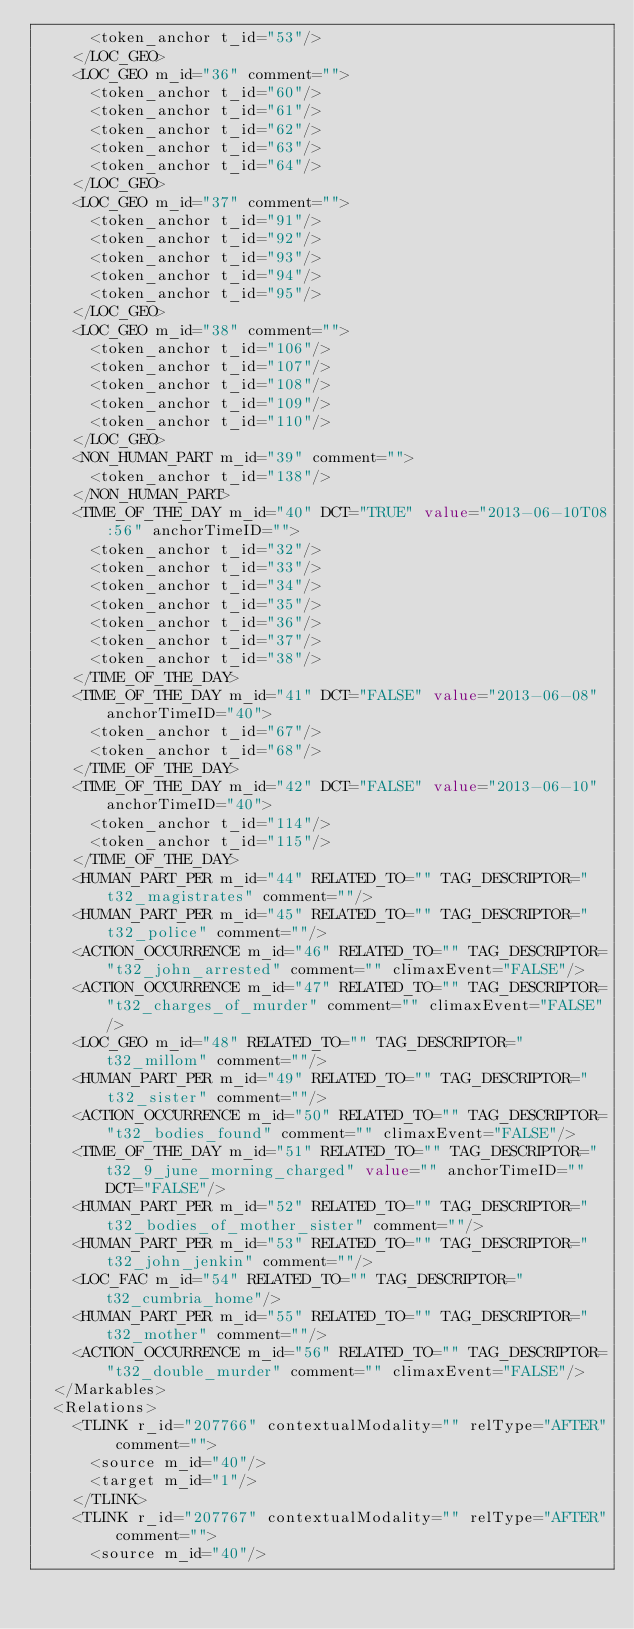Convert code to text. <code><loc_0><loc_0><loc_500><loc_500><_XML_>      <token_anchor t_id="53"/>
    </LOC_GEO>
    <LOC_GEO m_id="36" comment="">
      <token_anchor t_id="60"/>
      <token_anchor t_id="61"/>
      <token_anchor t_id="62"/>
      <token_anchor t_id="63"/>
      <token_anchor t_id="64"/>
    </LOC_GEO>
    <LOC_GEO m_id="37" comment="">
      <token_anchor t_id="91"/>
      <token_anchor t_id="92"/>
      <token_anchor t_id="93"/>
      <token_anchor t_id="94"/>
      <token_anchor t_id="95"/>
    </LOC_GEO>
    <LOC_GEO m_id="38" comment="">
      <token_anchor t_id="106"/>
      <token_anchor t_id="107"/>
      <token_anchor t_id="108"/>
      <token_anchor t_id="109"/>
      <token_anchor t_id="110"/>
    </LOC_GEO>
    <NON_HUMAN_PART m_id="39" comment="">
      <token_anchor t_id="138"/>
    </NON_HUMAN_PART>
    <TIME_OF_THE_DAY m_id="40" DCT="TRUE" value="2013-06-10T08:56" anchorTimeID="">
      <token_anchor t_id="32"/>
      <token_anchor t_id="33"/>
      <token_anchor t_id="34"/>
      <token_anchor t_id="35"/>
      <token_anchor t_id="36"/>
      <token_anchor t_id="37"/>
      <token_anchor t_id="38"/>
    </TIME_OF_THE_DAY>
    <TIME_OF_THE_DAY m_id="41" DCT="FALSE" value="2013-06-08" anchorTimeID="40">
      <token_anchor t_id="67"/>
      <token_anchor t_id="68"/>
    </TIME_OF_THE_DAY>
    <TIME_OF_THE_DAY m_id="42" DCT="FALSE" value="2013-06-10" anchorTimeID="40">
      <token_anchor t_id="114"/>
      <token_anchor t_id="115"/>
    </TIME_OF_THE_DAY>
    <HUMAN_PART_PER m_id="44" RELATED_TO="" TAG_DESCRIPTOR="t32_magistrates" comment=""/>
    <HUMAN_PART_PER m_id="45" RELATED_TO="" TAG_DESCRIPTOR="t32_police" comment=""/>
    <ACTION_OCCURRENCE m_id="46" RELATED_TO="" TAG_DESCRIPTOR="t32_john_arrested" comment="" climaxEvent="FALSE"/>
    <ACTION_OCCURRENCE m_id="47" RELATED_TO="" TAG_DESCRIPTOR="t32_charges_of_murder" comment="" climaxEvent="FALSE"/>
    <LOC_GEO m_id="48" RELATED_TO="" TAG_DESCRIPTOR="t32_millom" comment=""/>
    <HUMAN_PART_PER m_id="49" RELATED_TO="" TAG_DESCRIPTOR="t32_sister" comment=""/>
    <ACTION_OCCURRENCE m_id="50" RELATED_TO="" TAG_DESCRIPTOR="t32_bodies_found" comment="" climaxEvent="FALSE"/>
    <TIME_OF_THE_DAY m_id="51" RELATED_TO="" TAG_DESCRIPTOR="t32_9_june_morning_charged" value="" anchorTimeID="" DCT="FALSE"/>
    <HUMAN_PART_PER m_id="52" RELATED_TO="" TAG_DESCRIPTOR="t32_bodies_of_mother_sister" comment=""/>
    <HUMAN_PART_PER m_id="53" RELATED_TO="" TAG_DESCRIPTOR="t32_john_jenkin" comment=""/>
    <LOC_FAC m_id="54" RELATED_TO="" TAG_DESCRIPTOR="t32_cumbria_home"/>
    <HUMAN_PART_PER m_id="55" RELATED_TO="" TAG_DESCRIPTOR="t32_mother" comment=""/>
    <ACTION_OCCURRENCE m_id="56" RELATED_TO="" TAG_DESCRIPTOR="t32_double_murder" comment="" climaxEvent="FALSE"/>
  </Markables>
  <Relations>
    <TLINK r_id="207766" contextualModality="" relType="AFTER" comment="">
      <source m_id="40"/>
      <target m_id="1"/>
    </TLINK>
    <TLINK r_id="207767" contextualModality="" relType="AFTER" comment="">
      <source m_id="40"/></code> 